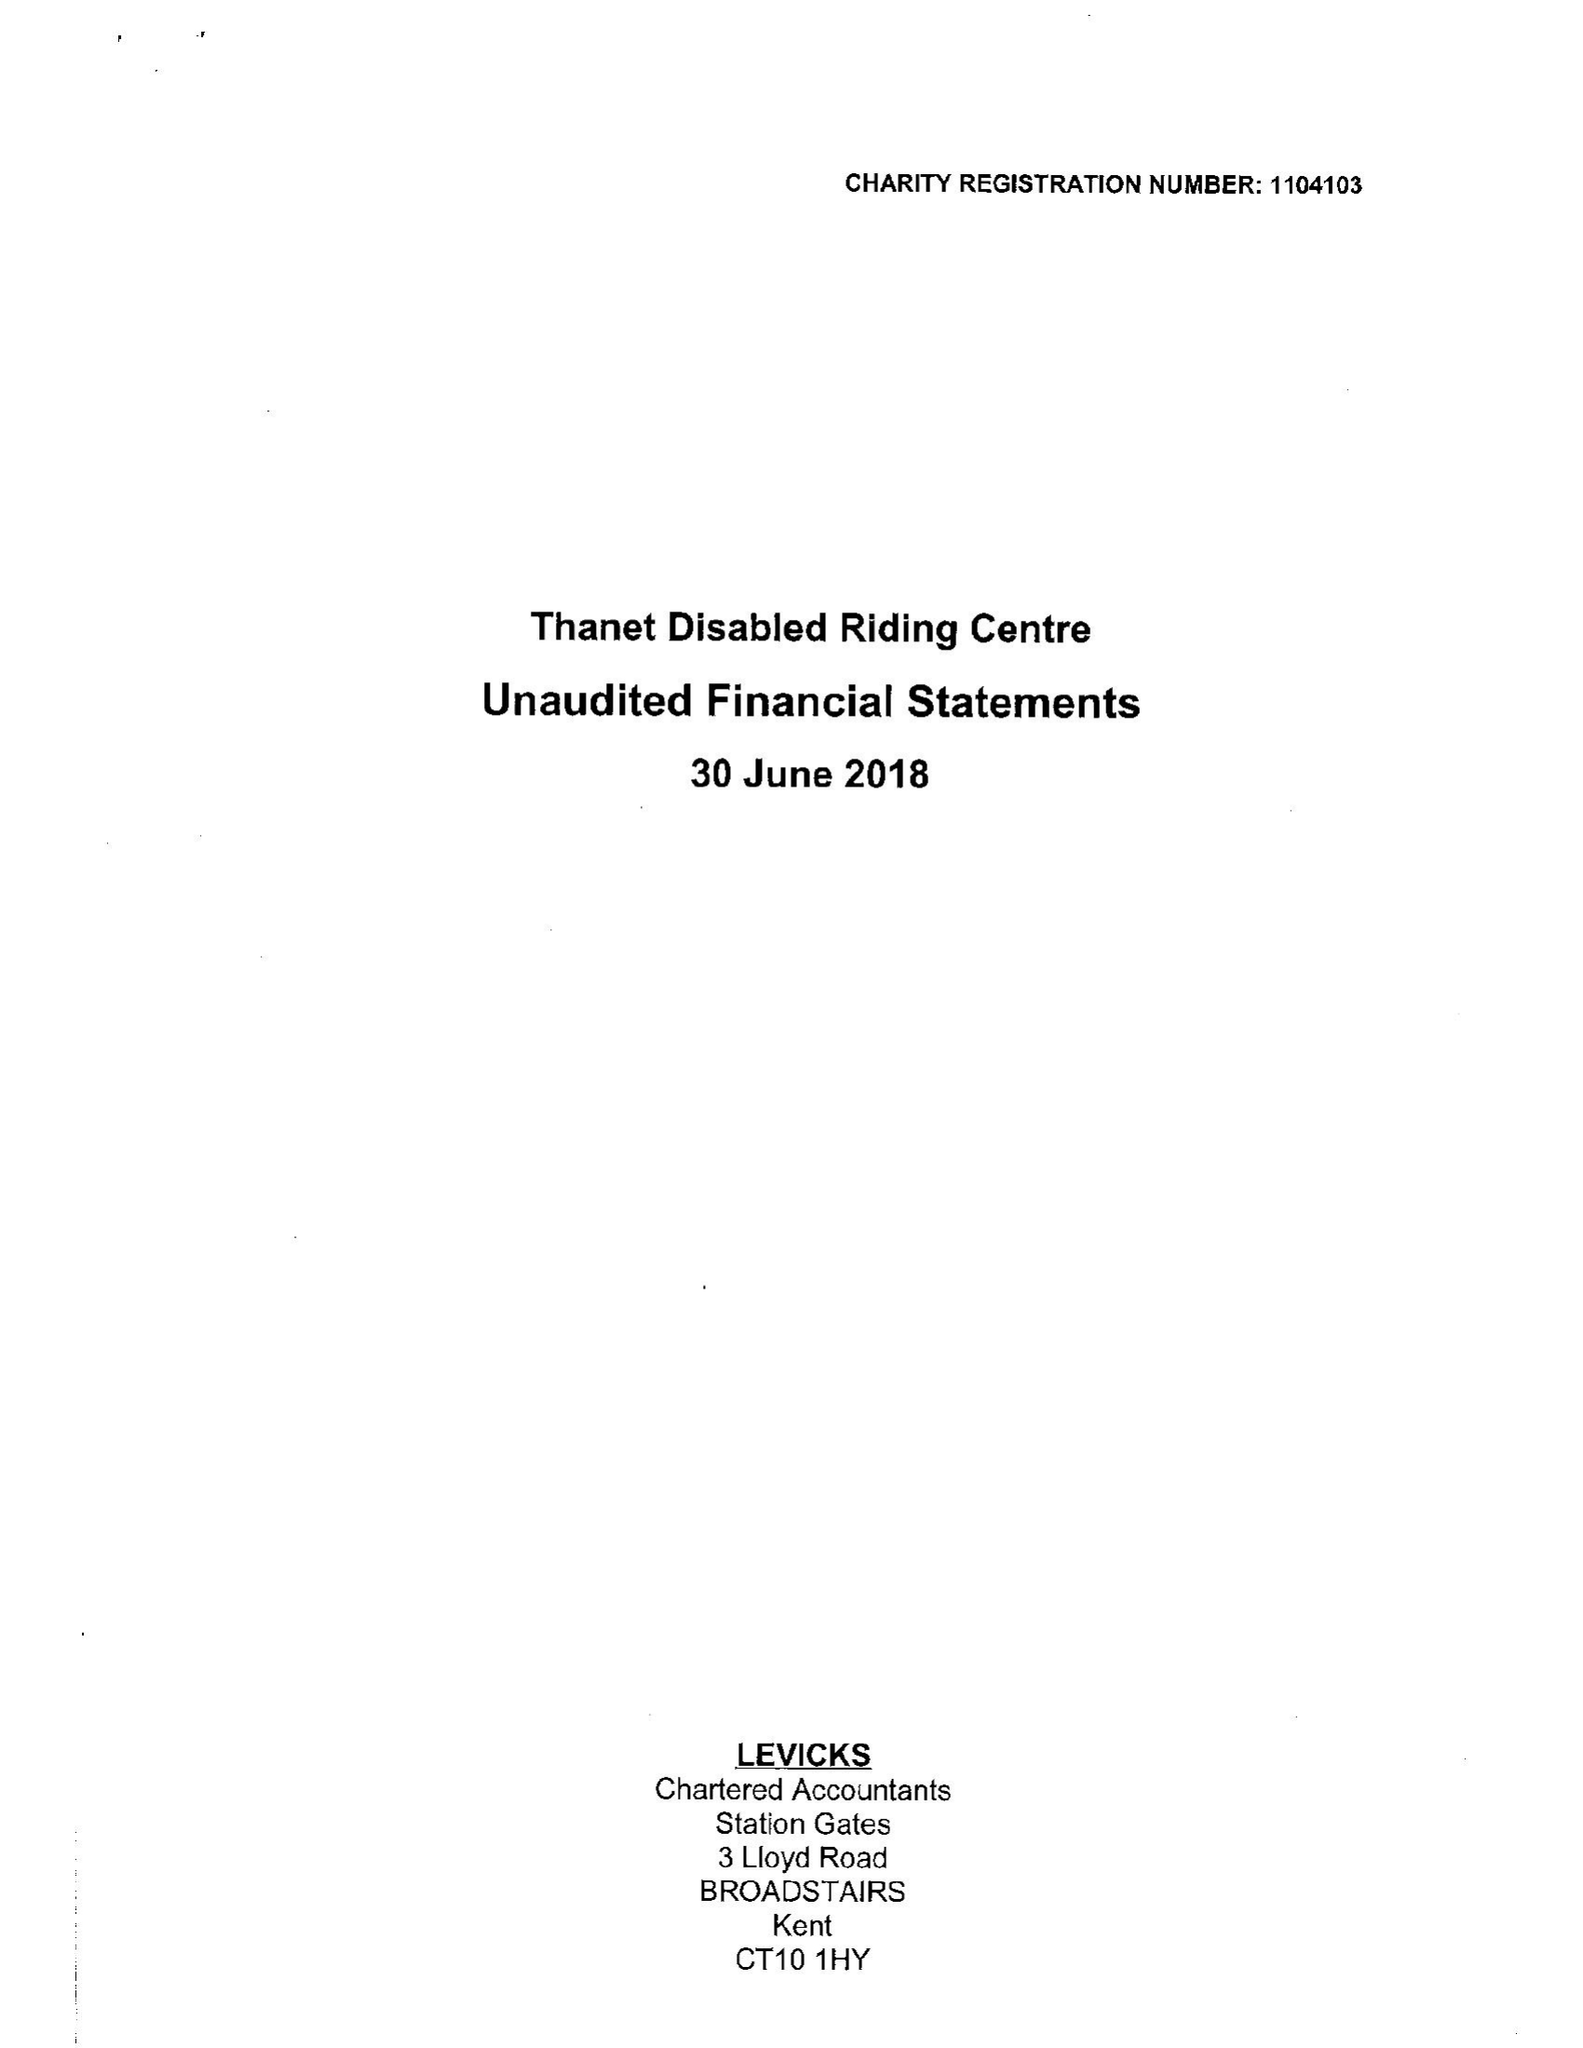What is the value for the address__postcode?
Answer the question using a single word or phrase. CT10 3AH 